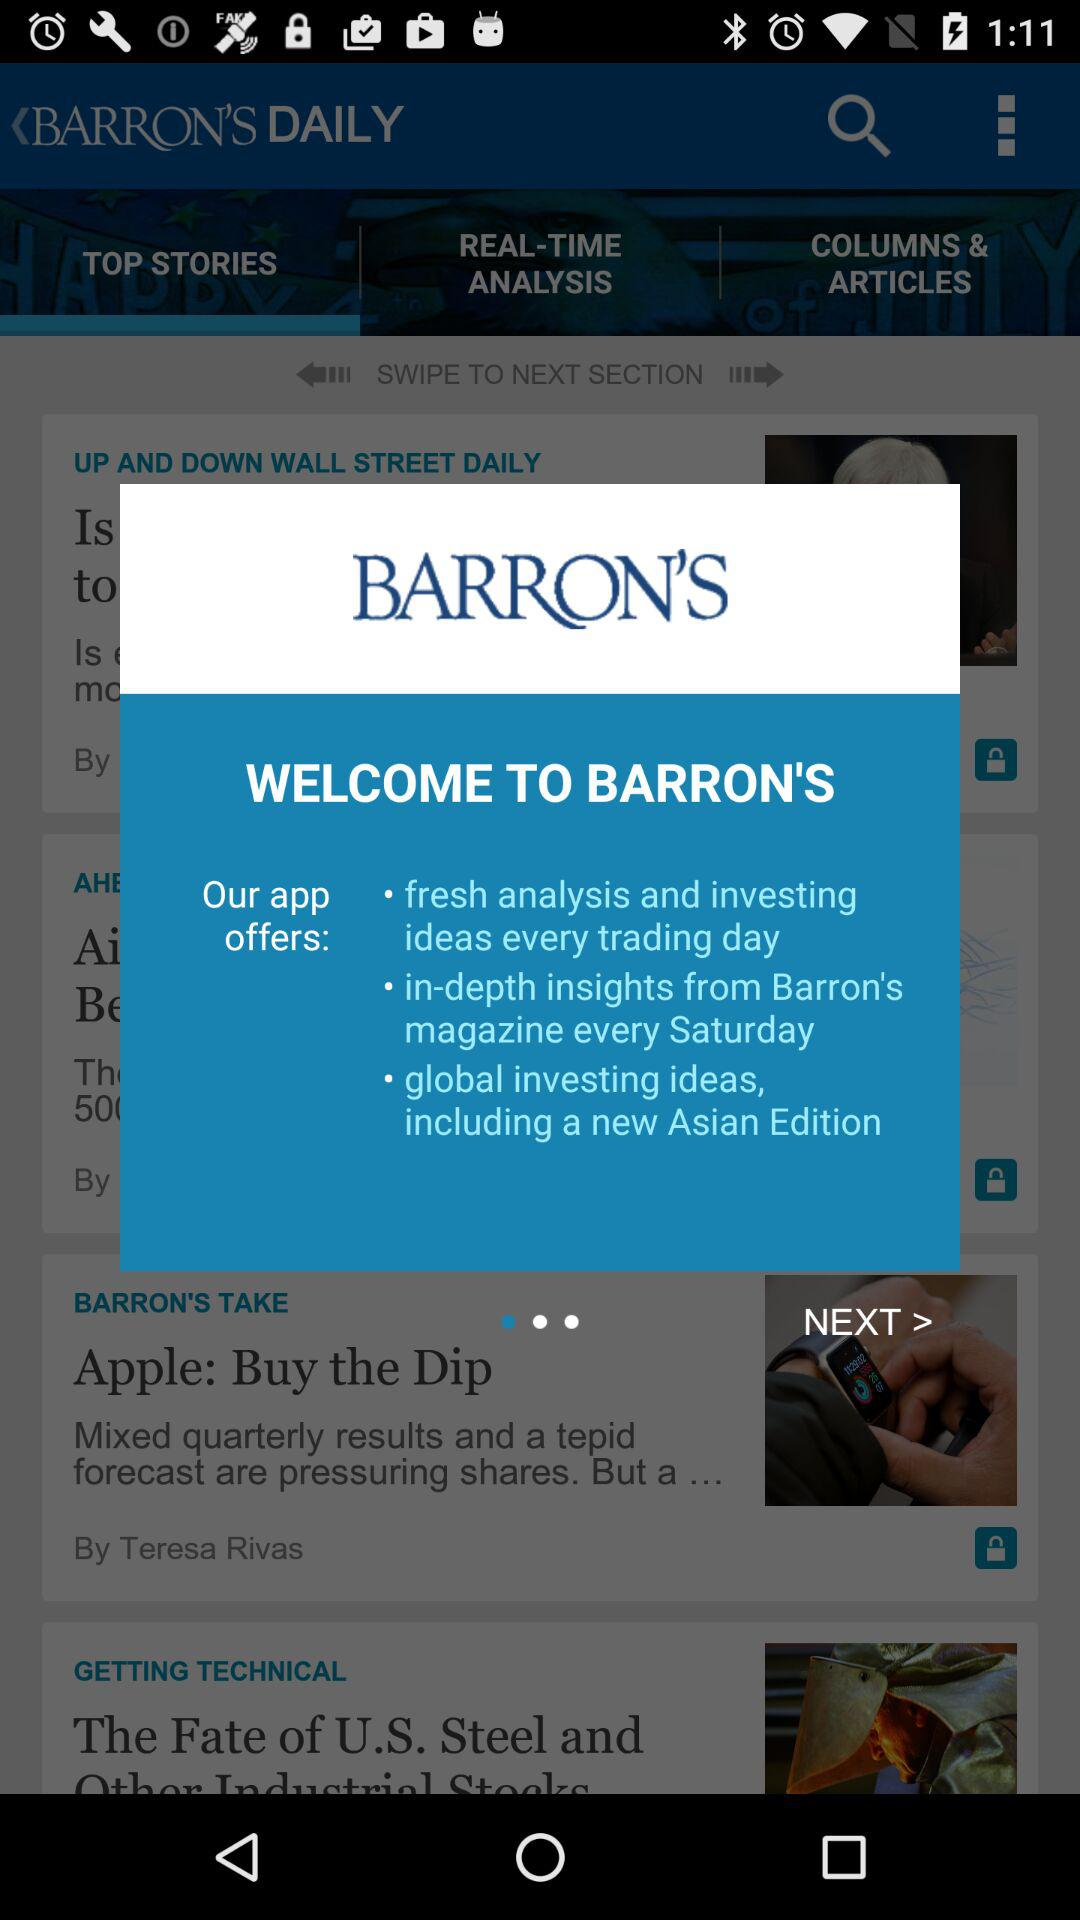How many sentences are in the app description?
Answer the question using a single word or phrase. 3 